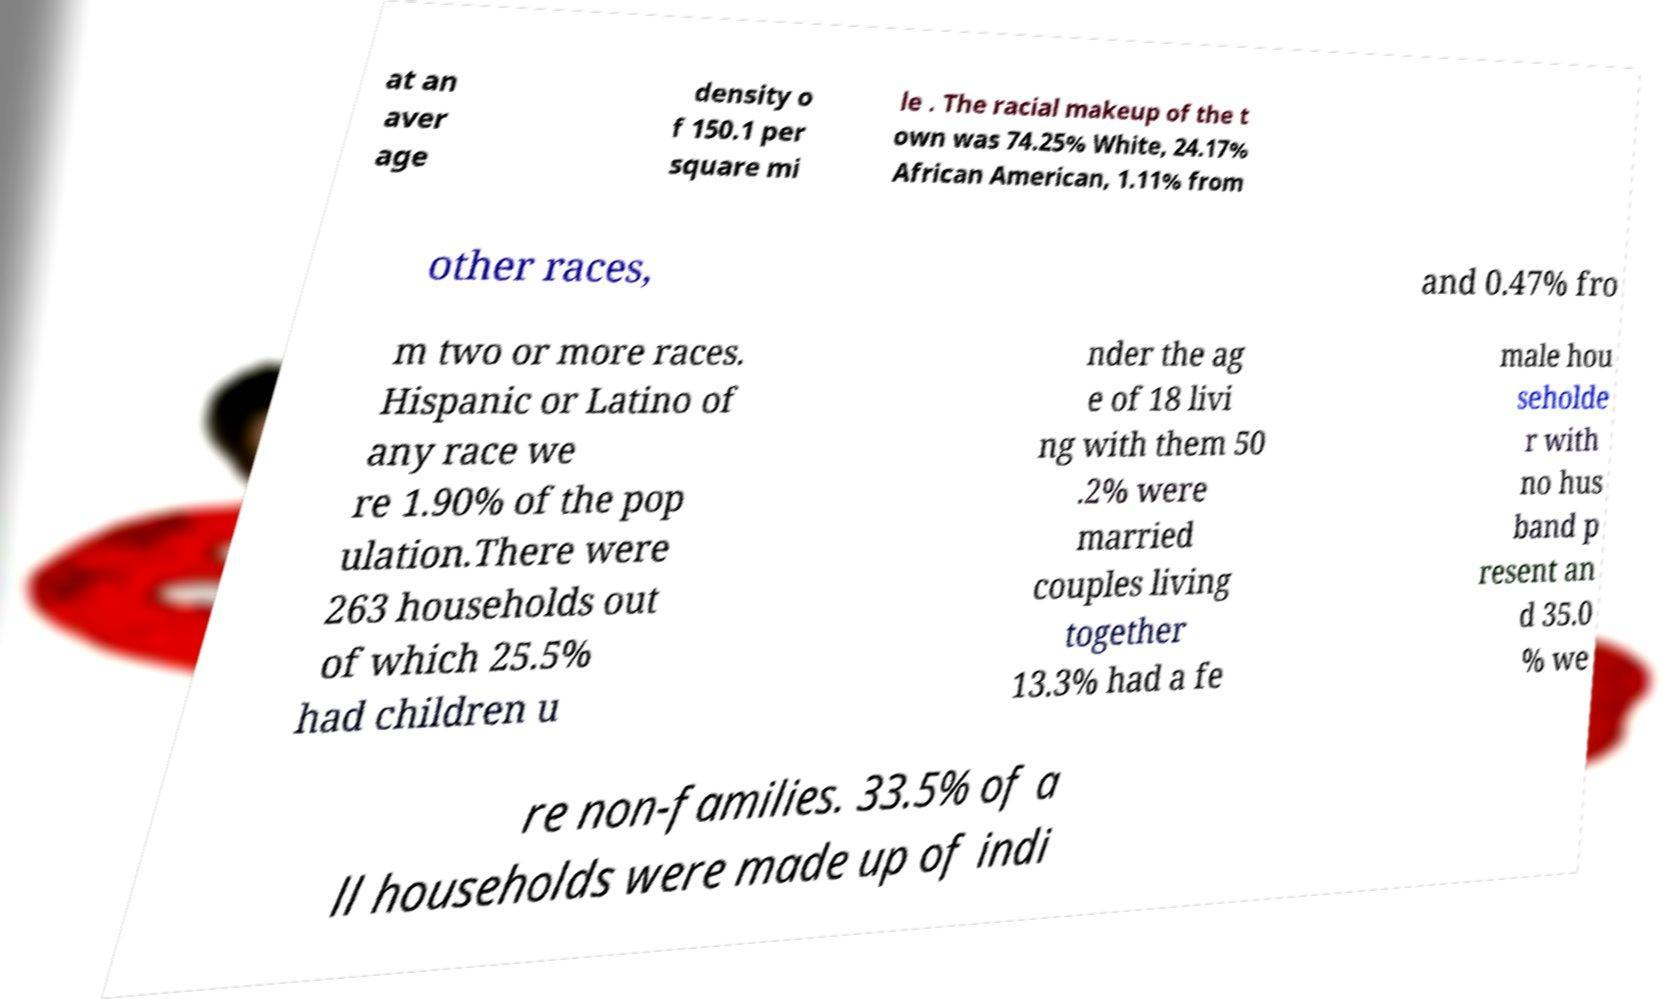Could you extract and type out the text from this image? at an aver age density o f 150.1 per square mi le . The racial makeup of the t own was 74.25% White, 24.17% African American, 1.11% from other races, and 0.47% fro m two or more races. Hispanic or Latino of any race we re 1.90% of the pop ulation.There were 263 households out of which 25.5% had children u nder the ag e of 18 livi ng with them 50 .2% were married couples living together 13.3% had a fe male hou seholde r with no hus band p resent an d 35.0 % we re non-families. 33.5% of a ll households were made up of indi 